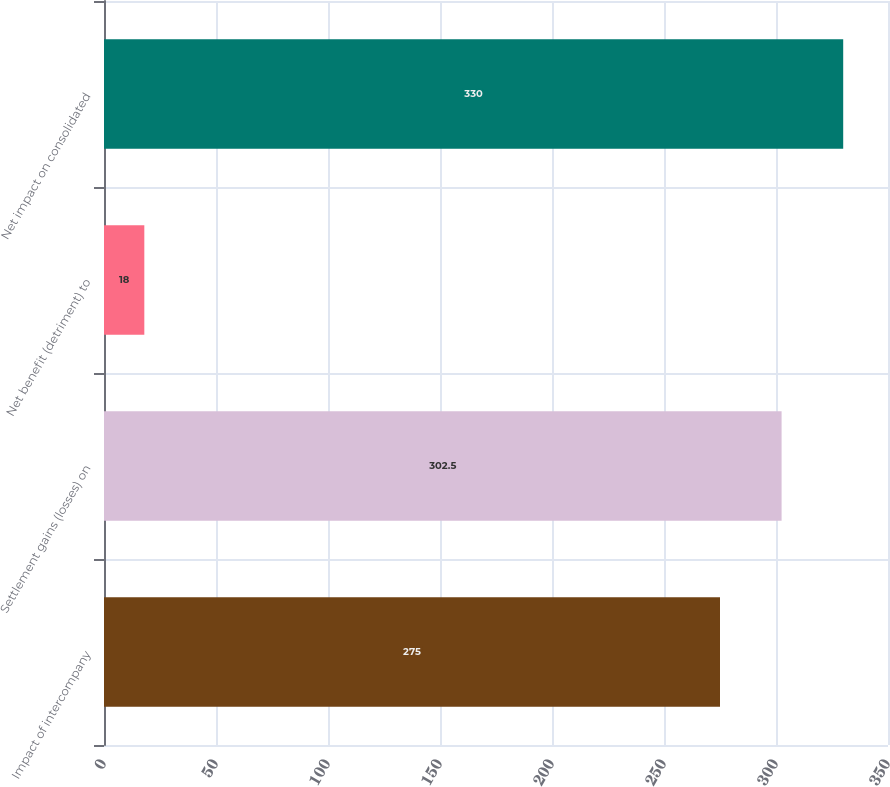<chart> <loc_0><loc_0><loc_500><loc_500><bar_chart><fcel>Impact of intercompany<fcel>Settlement gains (losses) on<fcel>Net benefit (detriment) to<fcel>Net impact on consolidated<nl><fcel>275<fcel>302.5<fcel>18<fcel>330<nl></chart> 